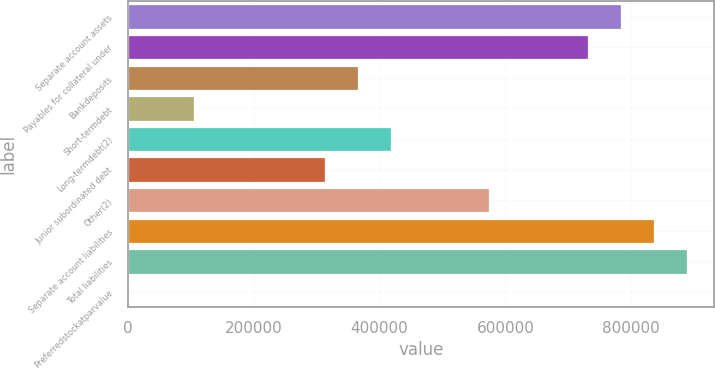<chart> <loc_0><loc_0><loc_500><loc_500><bar_chart><fcel>Separate account assets<fcel>Payables for collateral under<fcel>Bankdeposits<fcel>Short-termdebt<fcel>Long-termdebt(2)<fcel>Junior subordinated debt<fcel>Other(2)<fcel>Separate account liabilities<fcel>Total liabilities<fcel>Preferredstockatparvalue<nl><fcel>783246<fcel>731029<fcel>365515<fcel>104434<fcel>417731<fcel>313299<fcel>574380<fcel>835462<fcel>887678<fcel>1<nl></chart> 